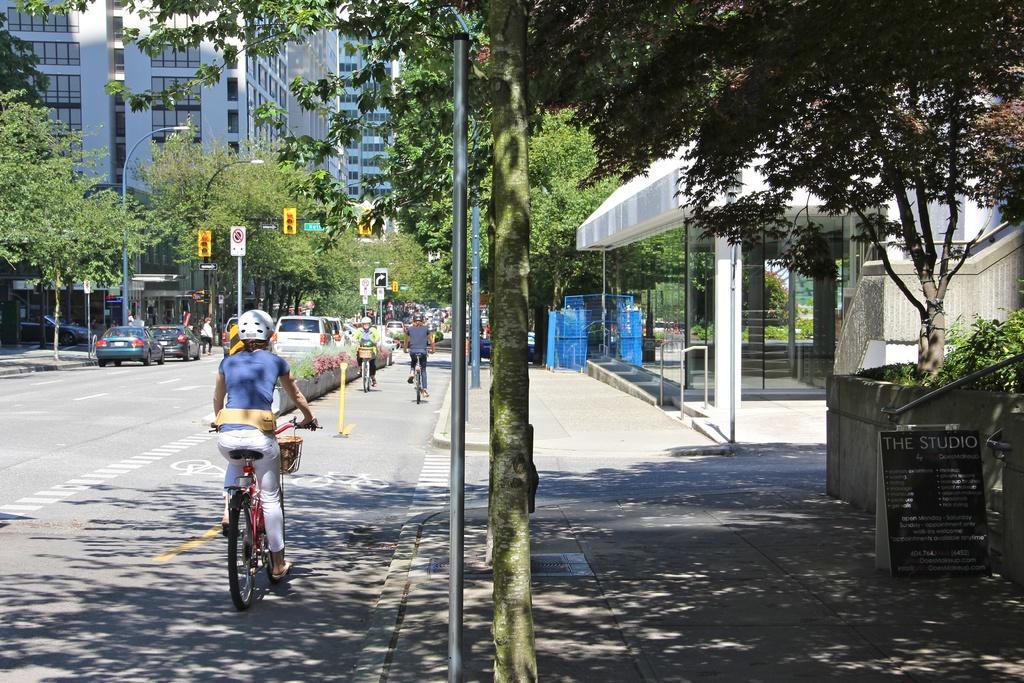How would you summarize this image in a sentence or two? In this image I can see the road. There are few vehicles on the road. And I can see few people are riding their bicycles and wearing the different color dresses and also the helmets. I can see the light poles, signals and boards to the side of the road. There are trees and also the building in the back. 